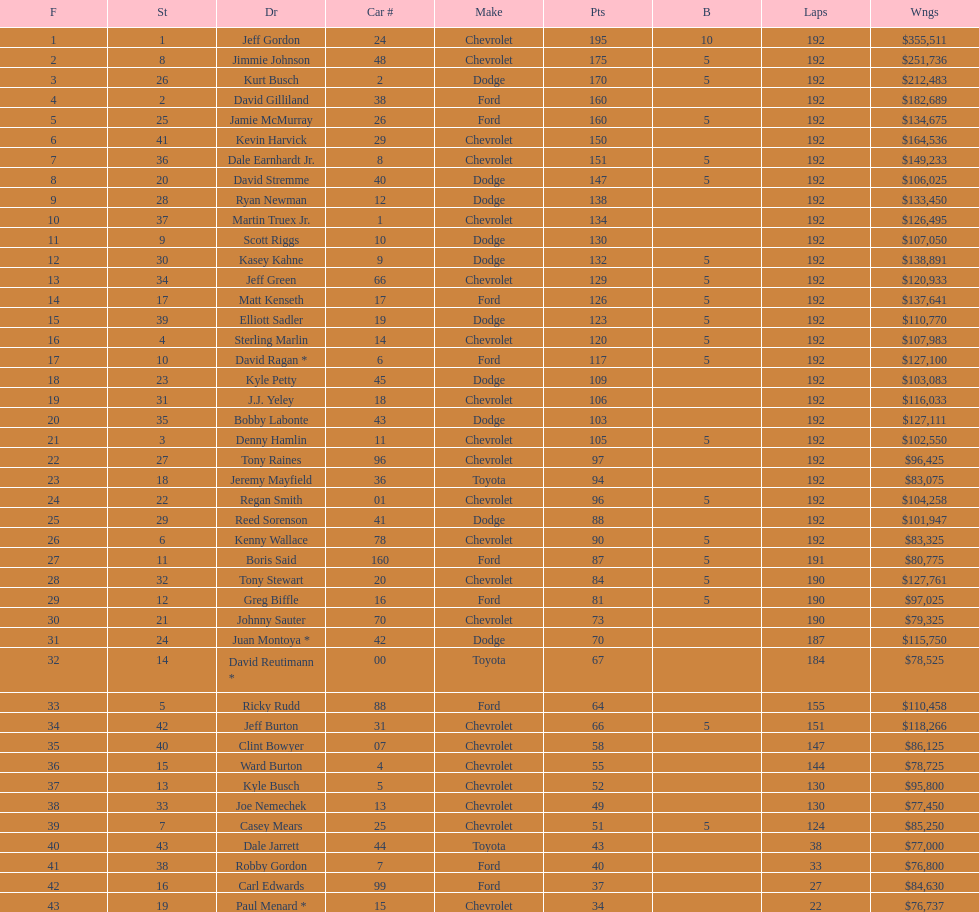Which make had the most consecutive finishes at the aarons 499? Chevrolet. 